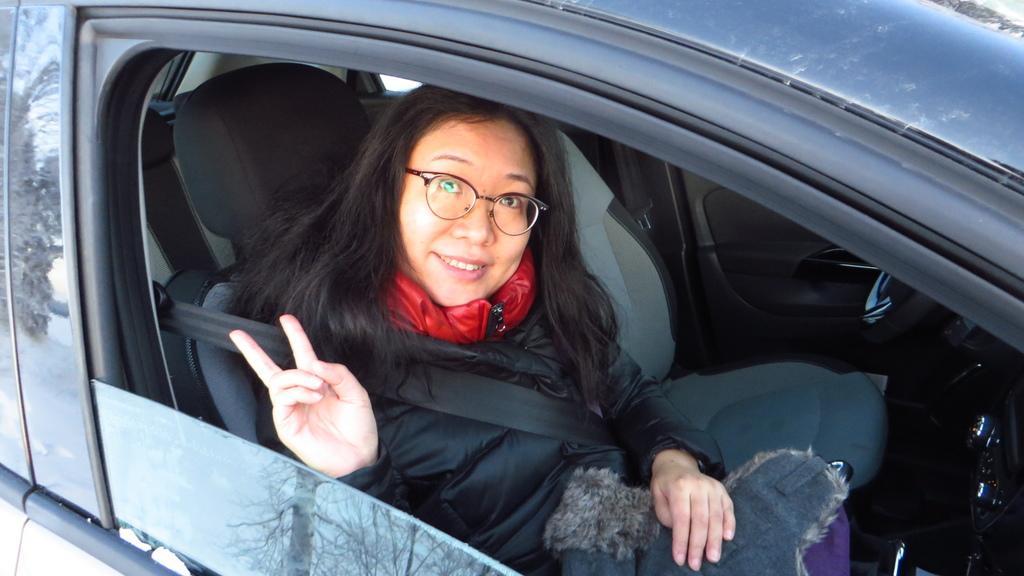Could you give a brief overview of what you see in this image? In this image a car is visible of blue in color in which woman is sitting on the seat and a staring visible. In the left tree is visible. This woman is having a smile on her face and wearing a goggle. This image is taken on the road during day time. 